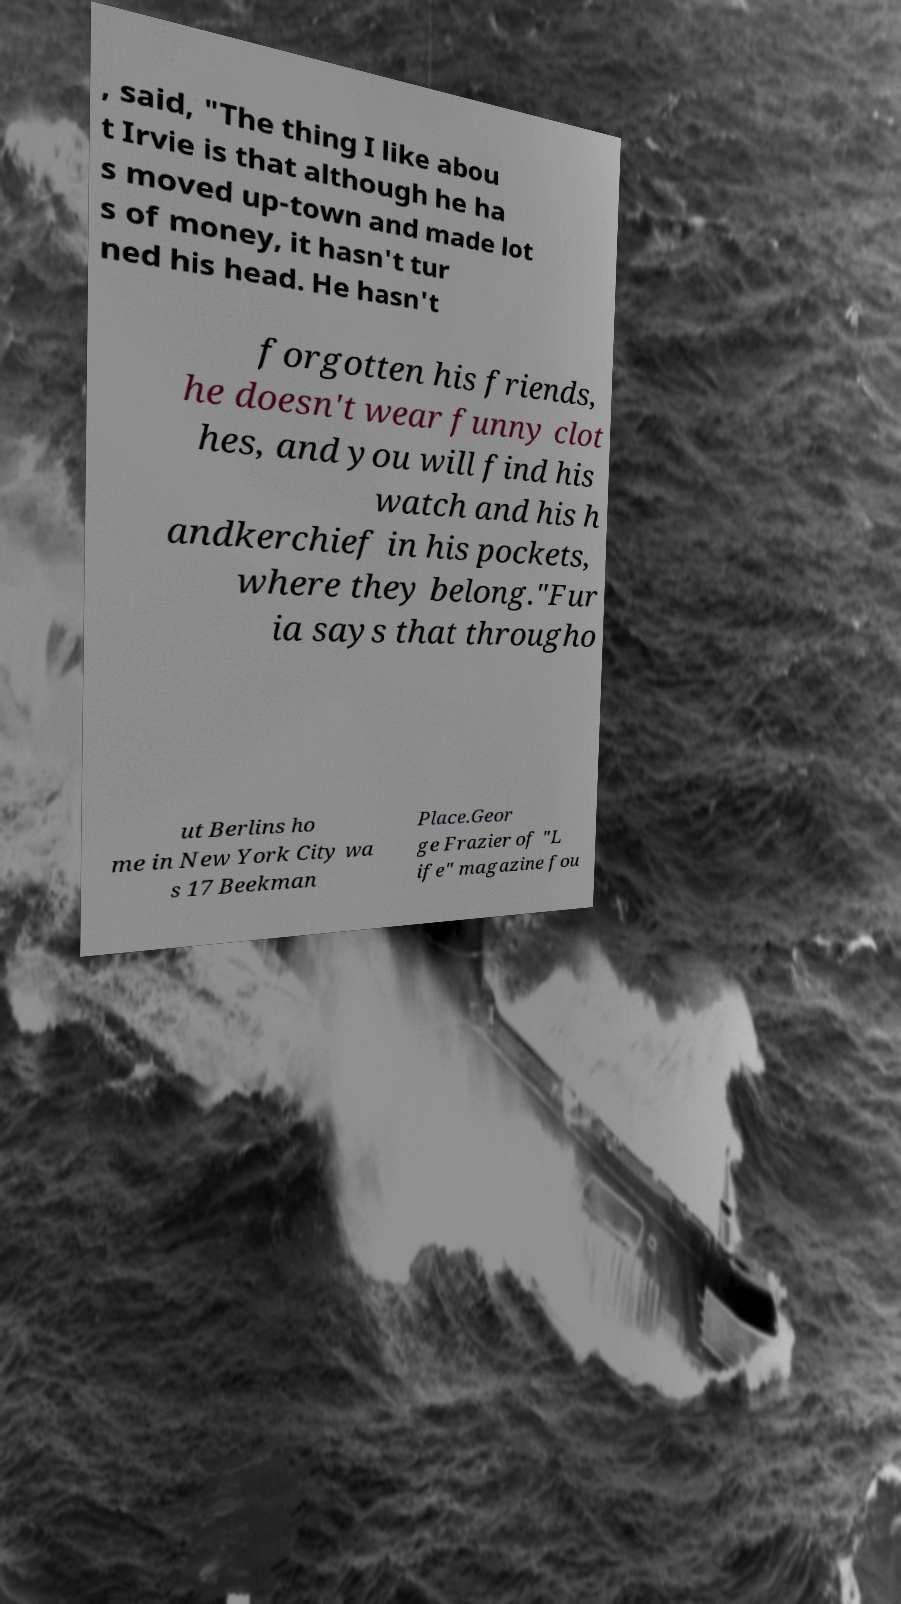Can you accurately transcribe the text from the provided image for me? , said, "The thing I like abou t Irvie is that although he ha s moved up-town and made lot s of money, it hasn't tur ned his head. He hasn't forgotten his friends, he doesn't wear funny clot hes, and you will find his watch and his h andkerchief in his pockets, where they belong."Fur ia says that througho ut Berlins ho me in New York City wa s 17 Beekman Place.Geor ge Frazier of "L ife" magazine fou 